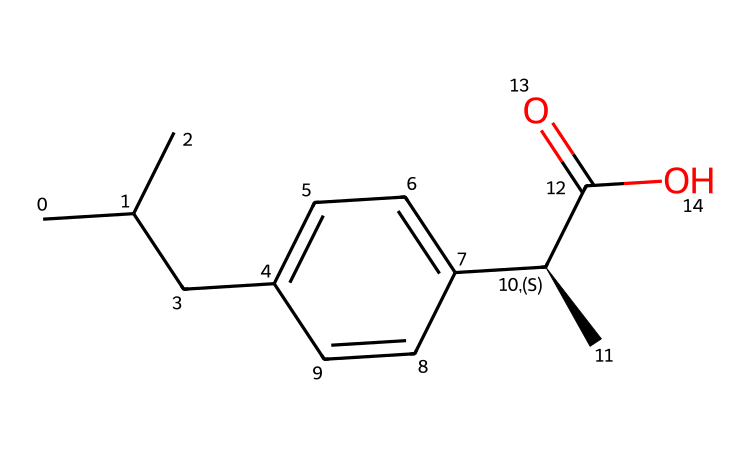What is the IUPAC name of this compound? The SMILES representation clearly shows that the compound has a carboxylic acid functional group (C(=O)O) and a specific branched structure, which leads to the IUPAC name: 2-(4-isobutylphenyl)propanoic acid.
Answer: 2-(4-isobutylphenyl)propanoic acid How many carbon atoms are present in ibuprofen? By analyzing the SMILES representation, we can count the carbon atoms: CC(C) indicates three carbons in the isobutyl group, the phenyl ring contributes six, and the two additional carbons in the propanoic acid structure. The total counts up to thirteen.
Answer: thirteen Does ibuprofen have chiral centers? The presence of the specification [C@H] in the SMILES notation indicates that there is a chiral center at that carbon atom. This means that ibuprofen is indeed a chiral compound.
Answer: yes What functional group is present at the end of ibuprofen's structure? The -COOH (carboxylic acid) group is visible at the end of the given chemical structure, indicating that ibuprofen has this functional group, which is responsible for its acidic properties.
Answer: carboxylic acid How many hydrogen atoms are connected to the chiral carbon in ibuprofen? Looking at the chiral carbon denoted by [C@H], we can see it is connected to three other groups: a carbon chain, a hydrogen atom, and another carbon atom with a bond to a functional group. Counting the connections shows that there is one hydrogen attached to the chiral center.
Answer: one 